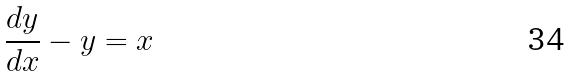<formula> <loc_0><loc_0><loc_500><loc_500>\frac { d y } { d x } - y = x</formula> 